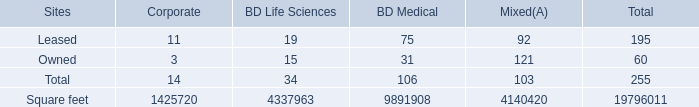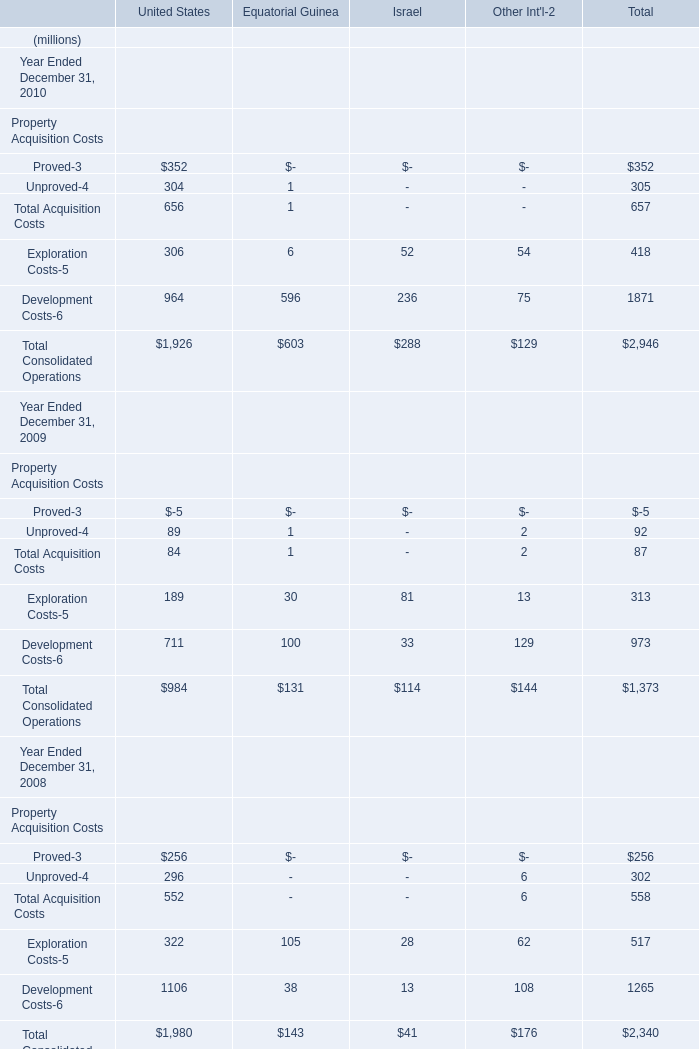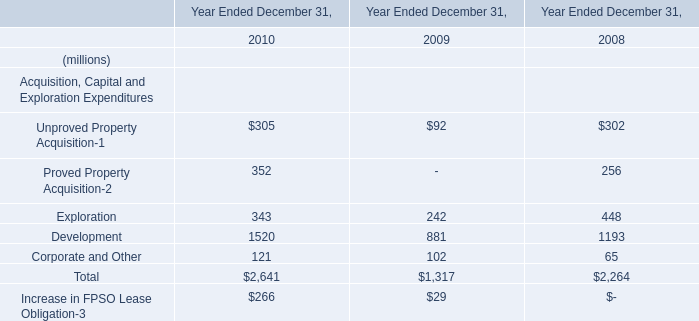What was the total amount of Total Acquisition Costs, Exploration Costs,Development Costs and Total Consolidated Operations in 2008,in terms of United States? (in million) 
Computations: (((552 + 322) + 1106) + 1980)
Answer: 3960.0. What's the growth rate of the Total Acquisition Costs in terms of United States in 2010? 
Computations: ((656 - 84) / 84)
Answer: 6.80952. 